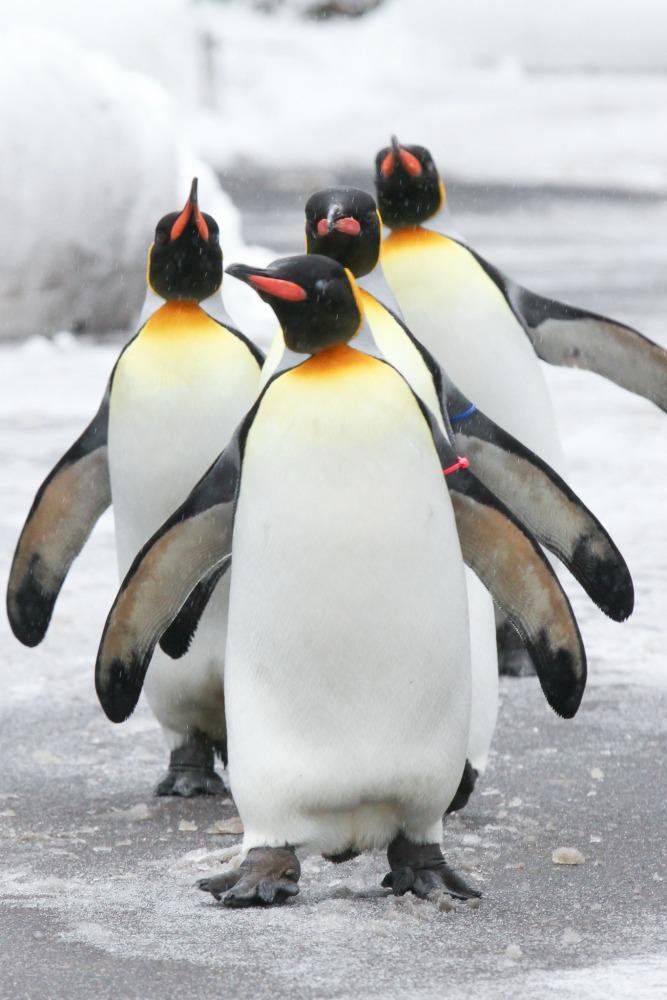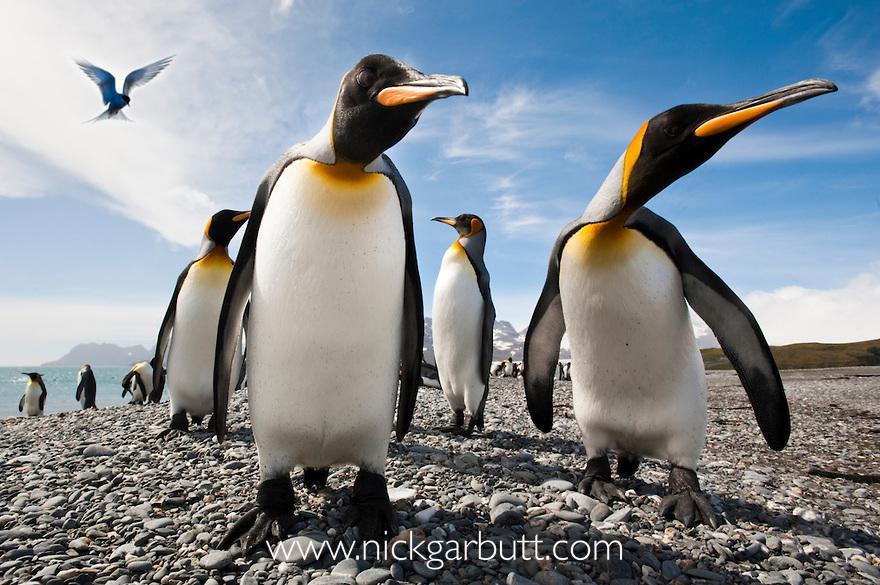The first image is the image on the left, the second image is the image on the right. Given the left and right images, does the statement "In at least one of the imagines there is a view of the beach with no more than 3 penguins walking together." hold true? Answer yes or no. No. The first image is the image on the left, the second image is the image on the right. Examine the images to the left and right. Is the description "Penguins in the left image are walking on ice." accurate? Answer yes or no. Yes. 